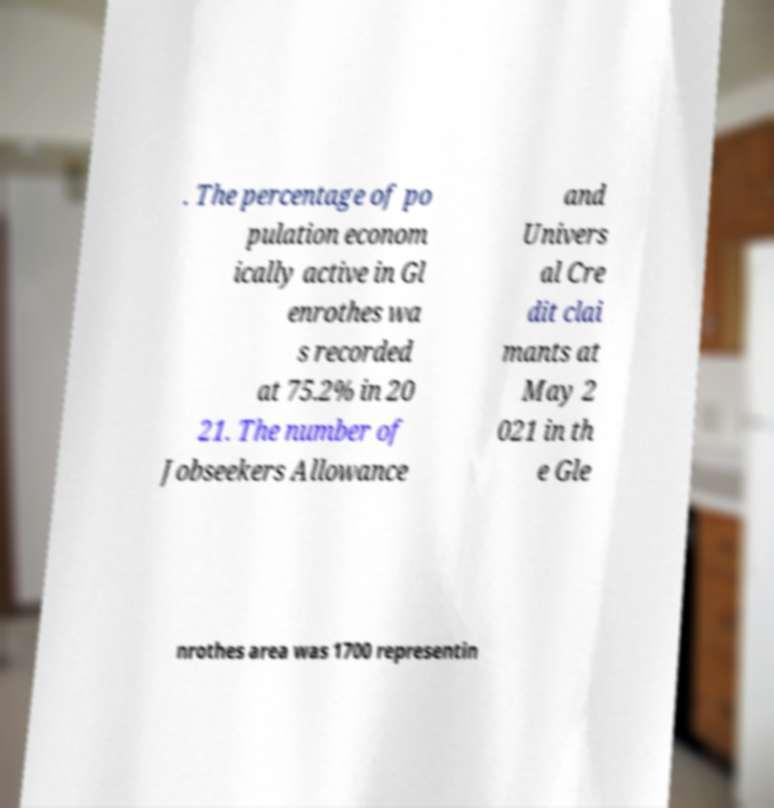Can you accurately transcribe the text from the provided image for me? . The percentage of po pulation econom ically active in Gl enrothes wa s recorded at 75.2% in 20 21. The number of Jobseekers Allowance and Univers al Cre dit clai mants at May 2 021 in th e Gle nrothes area was 1700 representin 